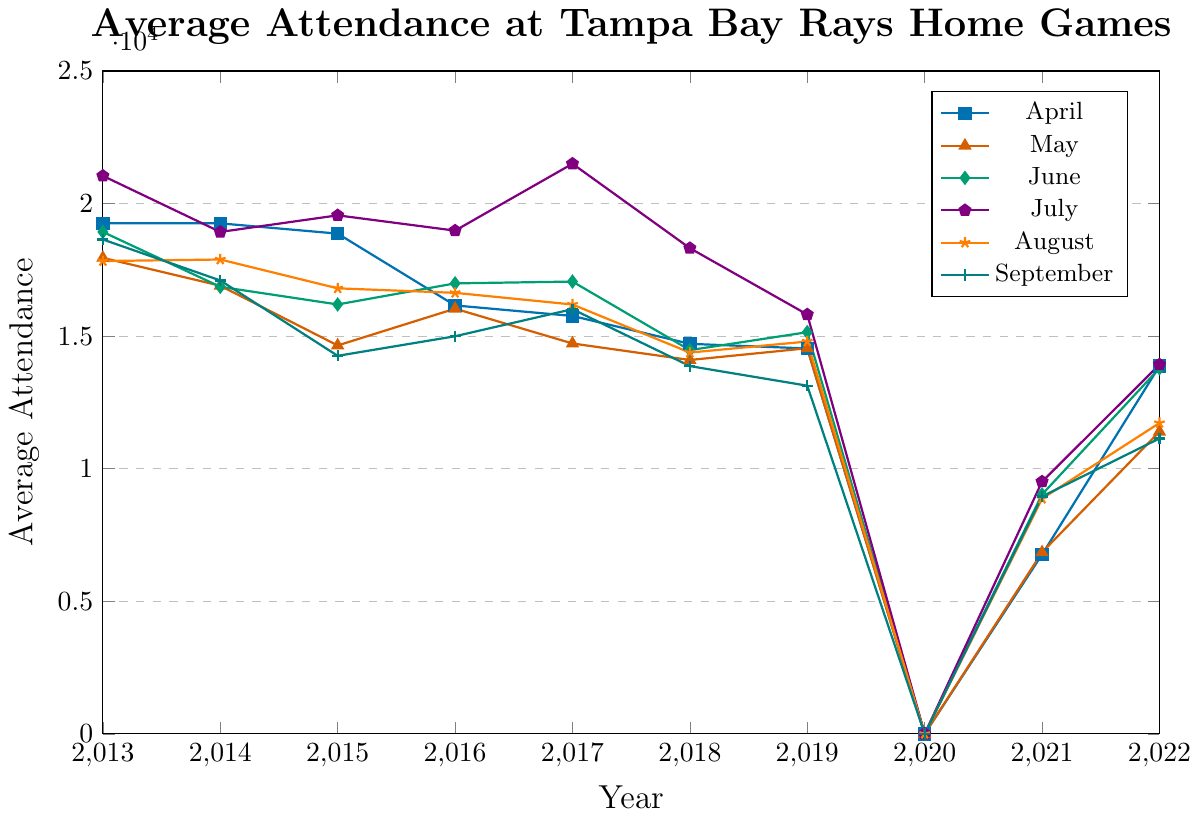Which month had the highest average attendance in 2017? To find the highest average attendance in 2017, look at each month and identify the maximum value. In 2017, July had the highest average attendance with 21,503.
Answer: July How did the average attendance in April 2022 compare to April 2019? Compare the average attendance values for April 2022 and April 2019. April 2019 had 14,536, and April 2022 had 13,873. Therefore, the attendance decreased.
Answer: Decreased Which month has the lowest average attendance over the entire decade? Identify the lowest values for each month and then compare them. The lowest value over the decade is in September 2019, with an average attendance of 13,132.
Answer: September 2019 What was the average attendance for June 2016 and June 2018? Look at the attendance for June 2016 and June 2018. June 2016 was 16,991 and June 2018 was 14,474. The average is (16,991 + 14,474) / 2 = 15,732.5.
Answer: 15,732.5 How did the COVID-19 pandemic affect the attendance figures in 2020? Examine the data for 2020. The attendance for July, August, and September 2020 are all zero, indicating no attendance due to the pandemic.
Answer: No attendance Is the trend for average attendance in July generally increasing or decreasing from 2013 to 2022? Compare the average attendance for July from 2013 to 2022. It starts at 21,046 in 2013 and ends at 13,927 in 2022. The general trend is decreasing.
Answer: Decreasing What is the difference in average attendance between the highest and lowest months in 2015? Identify the highest and lowest values in 2015. July is highest with 19,557, and September is lowest with 14,259. The difference is 19,557 - 14,259 = 5,298.
Answer: 5,298 During which year did the average attendance in every month (where available) consistently decrease compared to the previous year? Check each year to see if the average attendance for all months is lower than the previous year. In 2018, every month's attendance is lower compared to 2017.
Answer: 2018 What was the combined average attendance for April and May 2021? Find the average attendance for April and May 2021 which are 6,764 and 6,846. The combined average is (6,764 + 6,846) / 2 = 6,805.
Answer: 6,805 